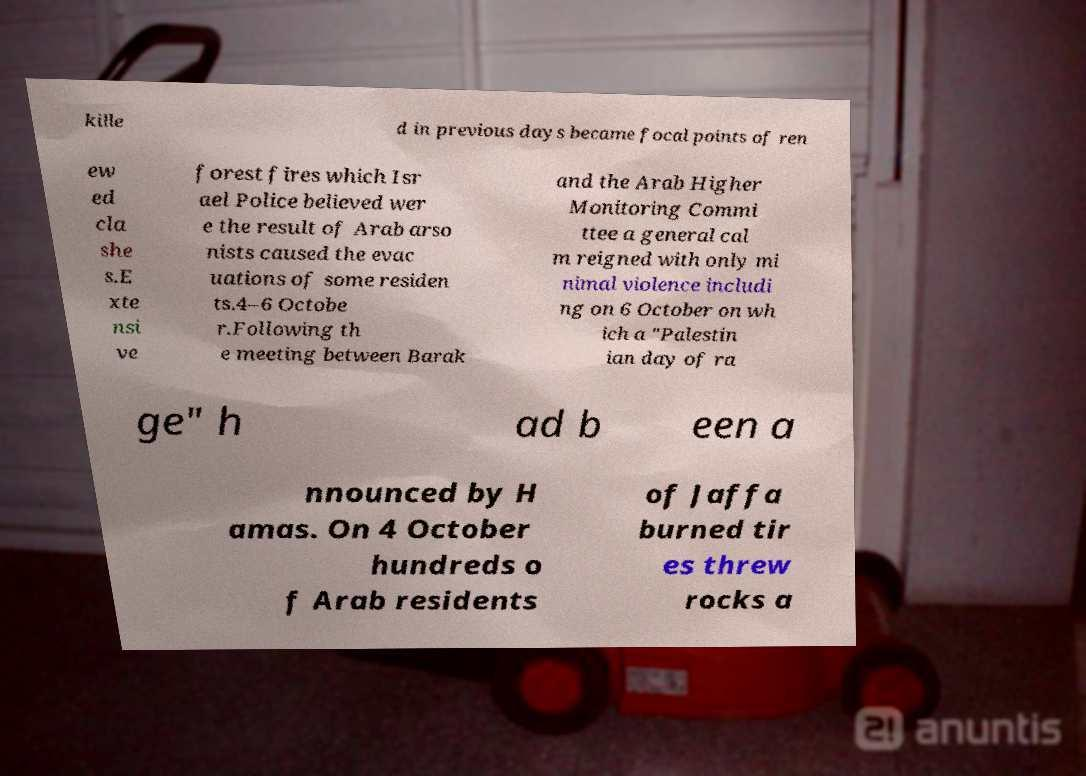For documentation purposes, I need the text within this image transcribed. Could you provide that? kille d in previous days became focal points of ren ew ed cla she s.E xte nsi ve forest fires which Isr ael Police believed wer e the result of Arab arso nists caused the evac uations of some residen ts.4–6 Octobe r.Following th e meeting between Barak and the Arab Higher Monitoring Commi ttee a general cal m reigned with only mi nimal violence includi ng on 6 October on wh ich a "Palestin ian day of ra ge" h ad b een a nnounced by H amas. On 4 October hundreds o f Arab residents of Jaffa burned tir es threw rocks a 